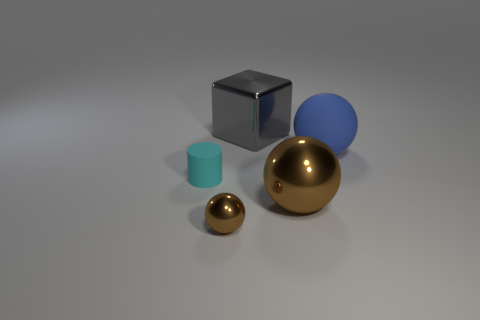Does the cyan thing have the same shape as the large gray metal thing?
Give a very brief answer. No. There is a sphere that is right of the metallic block and to the left of the big blue rubber thing; what is its color?
Ensure brevity in your answer.  Brown. The big matte ball has what color?
Offer a terse response. Blue. What material is the big object that is the same color as the small metal ball?
Your answer should be compact. Metal. Are there any brown metal things of the same shape as the small matte thing?
Provide a short and direct response. No. What is the size of the metal sphere that is to the left of the large metal cube?
Your answer should be very brief. Small. There is a cube that is the same size as the blue ball; what is its material?
Your answer should be compact. Metal. Are there more brown matte cubes than rubber balls?
Give a very brief answer. No. There is a metallic thing that is in front of the large metal thing in front of the cyan cylinder; how big is it?
Your response must be concise. Small. What is the shape of the brown shiny object that is the same size as the blue object?
Keep it short and to the point. Sphere. 